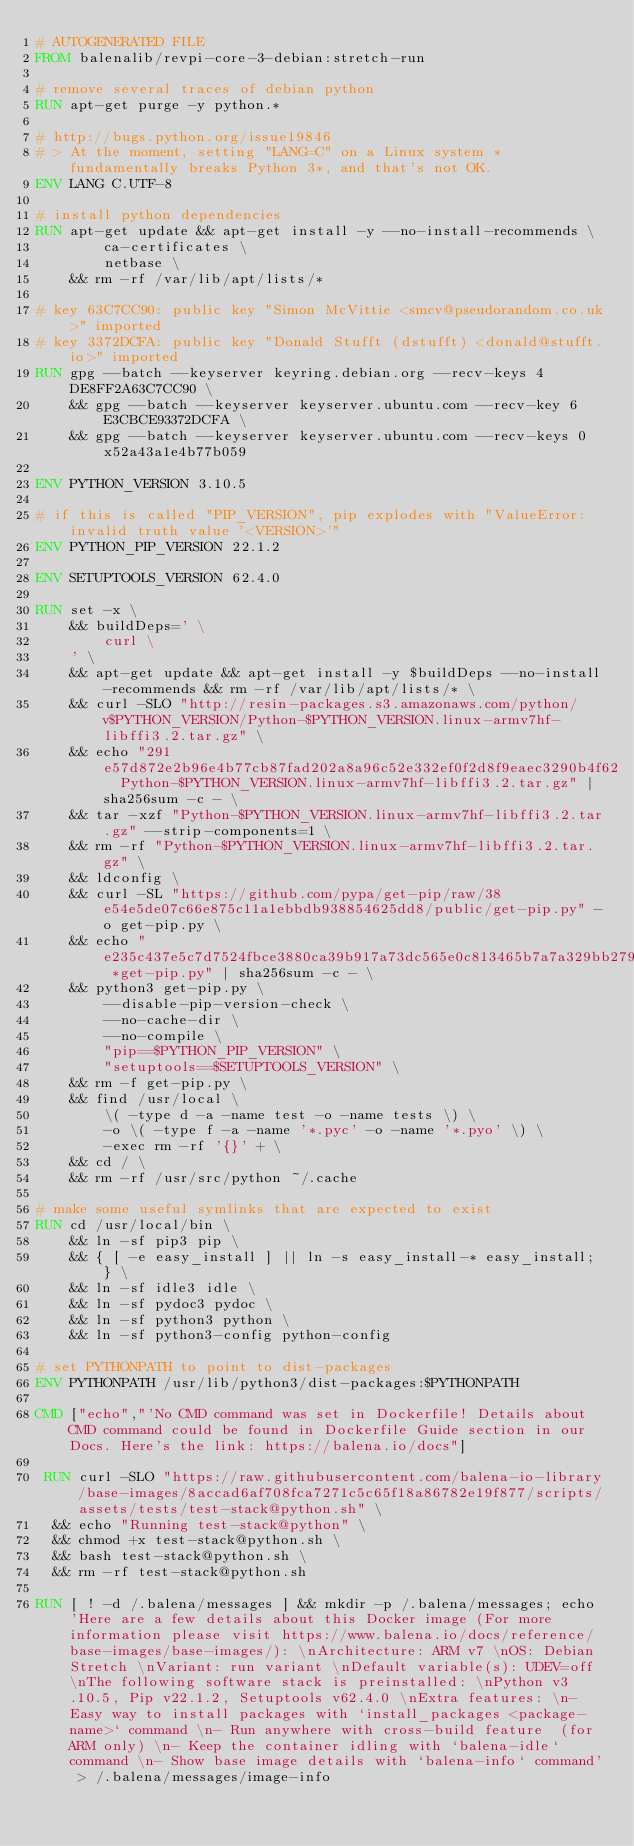Convert code to text. <code><loc_0><loc_0><loc_500><loc_500><_Dockerfile_># AUTOGENERATED FILE
FROM balenalib/revpi-core-3-debian:stretch-run

# remove several traces of debian python
RUN apt-get purge -y python.*

# http://bugs.python.org/issue19846
# > At the moment, setting "LANG=C" on a Linux system *fundamentally breaks Python 3*, and that's not OK.
ENV LANG C.UTF-8

# install python dependencies
RUN apt-get update && apt-get install -y --no-install-recommends \
		ca-certificates \
		netbase \
	&& rm -rf /var/lib/apt/lists/*

# key 63C7CC90: public key "Simon McVittie <smcv@pseudorandom.co.uk>" imported
# key 3372DCFA: public key "Donald Stufft (dstufft) <donald@stufft.io>" imported
RUN gpg --batch --keyserver keyring.debian.org --recv-keys 4DE8FF2A63C7CC90 \
	&& gpg --batch --keyserver keyserver.ubuntu.com --recv-key 6E3CBCE93372DCFA \
	&& gpg --batch --keyserver keyserver.ubuntu.com --recv-keys 0x52a43a1e4b77b059

ENV PYTHON_VERSION 3.10.5

# if this is called "PIP_VERSION", pip explodes with "ValueError: invalid truth value '<VERSION>'"
ENV PYTHON_PIP_VERSION 22.1.2

ENV SETUPTOOLS_VERSION 62.4.0

RUN set -x \
	&& buildDeps=' \
		curl \
	' \
	&& apt-get update && apt-get install -y $buildDeps --no-install-recommends && rm -rf /var/lib/apt/lists/* \
	&& curl -SLO "http://resin-packages.s3.amazonaws.com/python/v$PYTHON_VERSION/Python-$PYTHON_VERSION.linux-armv7hf-libffi3.2.tar.gz" \
	&& echo "291e57d872e2b96e4b77cb87fad202a8a96c52e332ef0f2d8f9eaec3290b4f62  Python-$PYTHON_VERSION.linux-armv7hf-libffi3.2.tar.gz" | sha256sum -c - \
	&& tar -xzf "Python-$PYTHON_VERSION.linux-armv7hf-libffi3.2.tar.gz" --strip-components=1 \
	&& rm -rf "Python-$PYTHON_VERSION.linux-armv7hf-libffi3.2.tar.gz" \
	&& ldconfig \
	&& curl -SL "https://github.com/pypa/get-pip/raw/38e54e5de07c66e875c11a1ebbdb938854625dd8/public/get-pip.py" -o get-pip.py \
    && echo "e235c437e5c7d7524fbce3880ca39b917a73dc565e0c813465b7a7a329bb279a *get-pip.py" | sha256sum -c - \
    && python3 get-pip.py \
        --disable-pip-version-check \
        --no-cache-dir \
        --no-compile \
        "pip==$PYTHON_PIP_VERSION" \
        "setuptools==$SETUPTOOLS_VERSION" \
	&& rm -f get-pip.py \
	&& find /usr/local \
		\( -type d -a -name test -o -name tests \) \
		-o \( -type f -a -name '*.pyc' -o -name '*.pyo' \) \
		-exec rm -rf '{}' + \
	&& cd / \
	&& rm -rf /usr/src/python ~/.cache

# make some useful symlinks that are expected to exist
RUN cd /usr/local/bin \
	&& ln -sf pip3 pip \
	&& { [ -e easy_install ] || ln -s easy_install-* easy_install; } \
	&& ln -sf idle3 idle \
	&& ln -sf pydoc3 pydoc \
	&& ln -sf python3 python \
	&& ln -sf python3-config python-config

# set PYTHONPATH to point to dist-packages
ENV PYTHONPATH /usr/lib/python3/dist-packages:$PYTHONPATH

CMD ["echo","'No CMD command was set in Dockerfile! Details about CMD command could be found in Dockerfile Guide section in our Docs. Here's the link: https://balena.io/docs"]

 RUN curl -SLO "https://raw.githubusercontent.com/balena-io-library/base-images/8accad6af708fca7271c5c65f18a86782e19f877/scripts/assets/tests/test-stack@python.sh" \
  && echo "Running test-stack@python" \
  && chmod +x test-stack@python.sh \
  && bash test-stack@python.sh \
  && rm -rf test-stack@python.sh 

RUN [ ! -d /.balena/messages ] && mkdir -p /.balena/messages; echo 'Here are a few details about this Docker image (For more information please visit https://www.balena.io/docs/reference/base-images/base-images/): \nArchitecture: ARM v7 \nOS: Debian Stretch \nVariant: run variant \nDefault variable(s): UDEV=off \nThe following software stack is preinstalled: \nPython v3.10.5, Pip v22.1.2, Setuptools v62.4.0 \nExtra features: \n- Easy way to install packages with `install_packages <package-name>` command \n- Run anywhere with cross-build feature  (for ARM only) \n- Keep the container idling with `balena-idle` command \n- Show base image details with `balena-info` command' > /.balena/messages/image-info</code> 